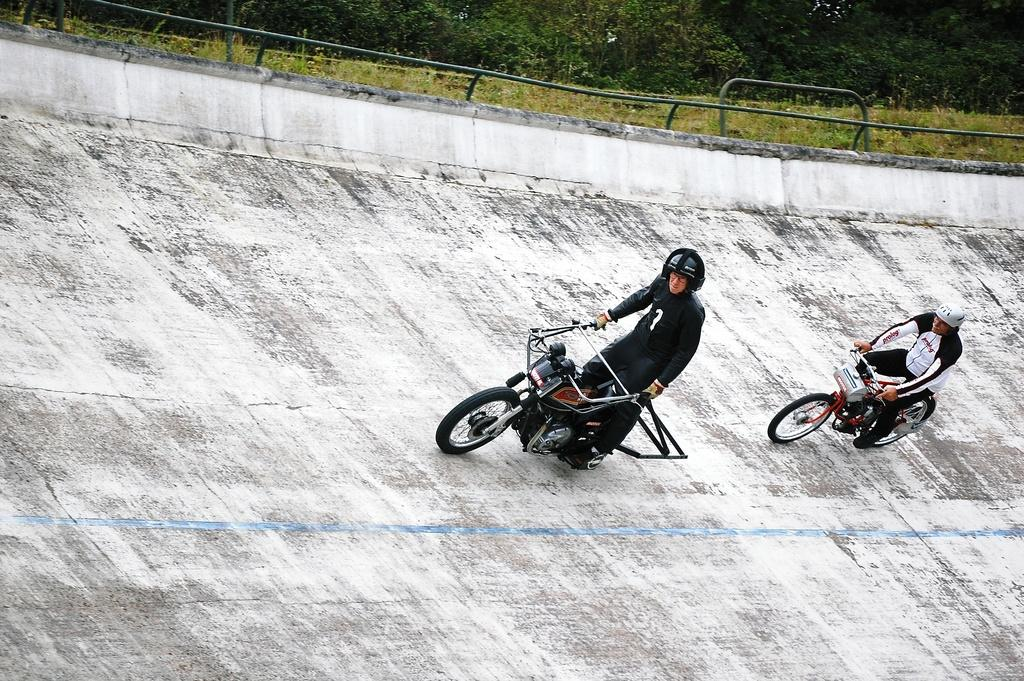How many people are in the image? There are two people in the image. What are the two people doing in the image? The two people are riding a bike. Where is the bike located in the image? The bike is on a slope wall. Can you see a store in the image? There is no store present in the image. Is the moon visible in the image? The moon is not visible in the image. 